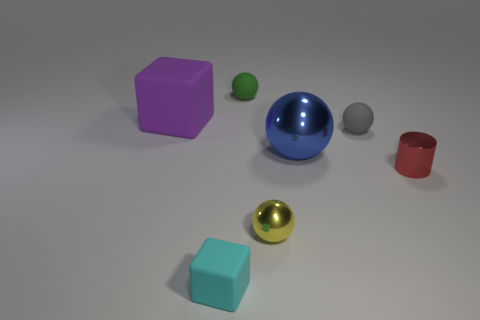What number of things are either cyan matte things or large red metal spheres?
Give a very brief answer. 1. There is a tiny metallic object that is on the right side of the tiny yellow metal ball; is its shape the same as the green object?
Offer a very short reply. No. The rubber cube in front of the rubber object left of the cyan thing is what color?
Your response must be concise. Cyan. Are there fewer small purple shiny things than tiny red shiny objects?
Your answer should be compact. Yes. Is there a tiny yellow sphere made of the same material as the big cube?
Ensure brevity in your answer.  No. There is a small green thing; is its shape the same as the big object to the right of the tiny green object?
Your response must be concise. Yes. Are there any small green balls in front of the large blue metallic sphere?
Give a very brief answer. No. What number of gray objects are the same shape as the yellow thing?
Offer a terse response. 1. Is the material of the red cylinder the same as the tiny thing to the left of the small green matte sphere?
Your answer should be compact. No. What number of blue balls are there?
Keep it short and to the point. 1. 